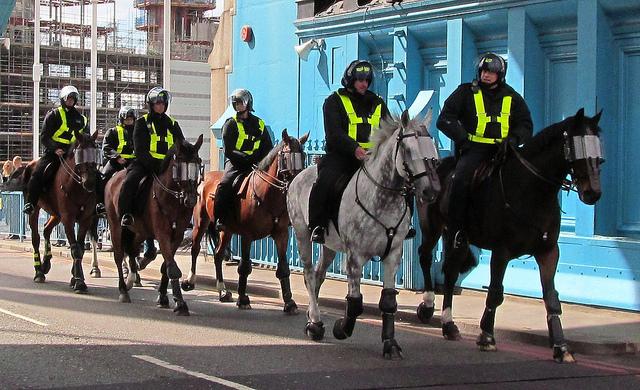Is this a parade?
Write a very short answer. No. How many horses are in the photo?
Short answer required. 6. How many people are riding?
Give a very brief answer. 6. 